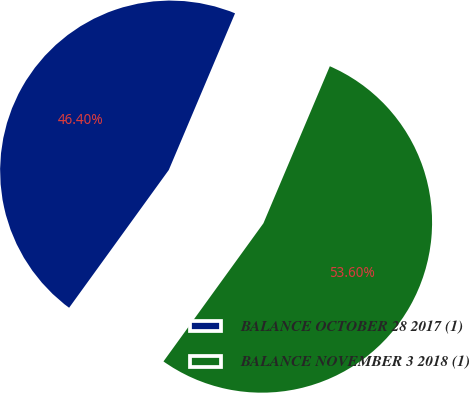<chart> <loc_0><loc_0><loc_500><loc_500><pie_chart><fcel>BALANCE OCTOBER 28 2017 (1)<fcel>BALANCE NOVEMBER 3 2018 (1)<nl><fcel>46.4%<fcel>53.6%<nl></chart> 